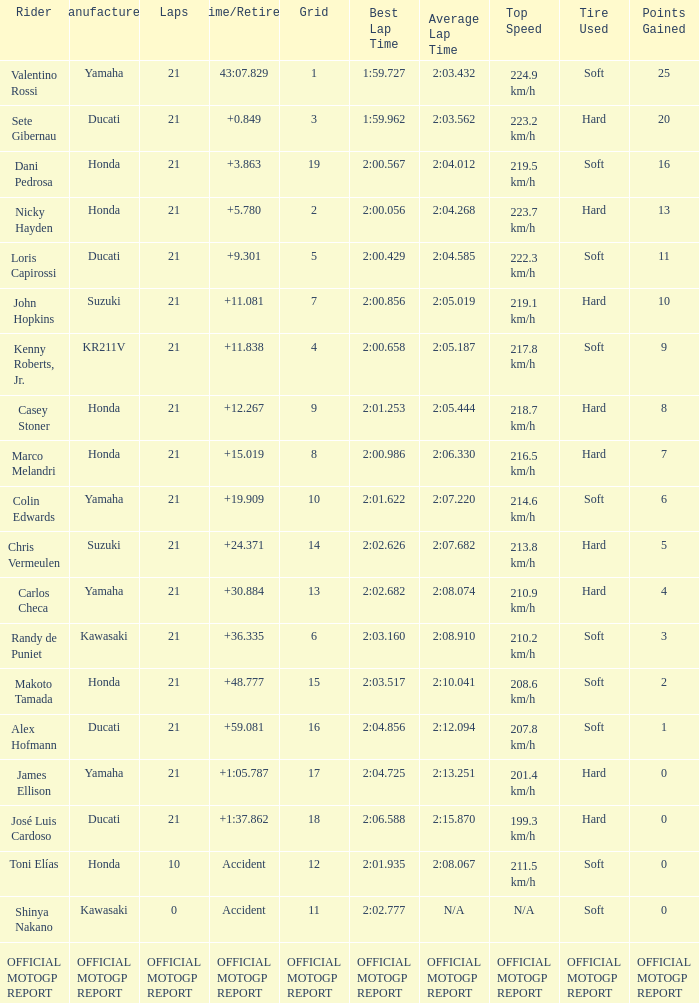How many laps did Valentino rossi have when riding a vehicle manufactured by yamaha? 21.0. 